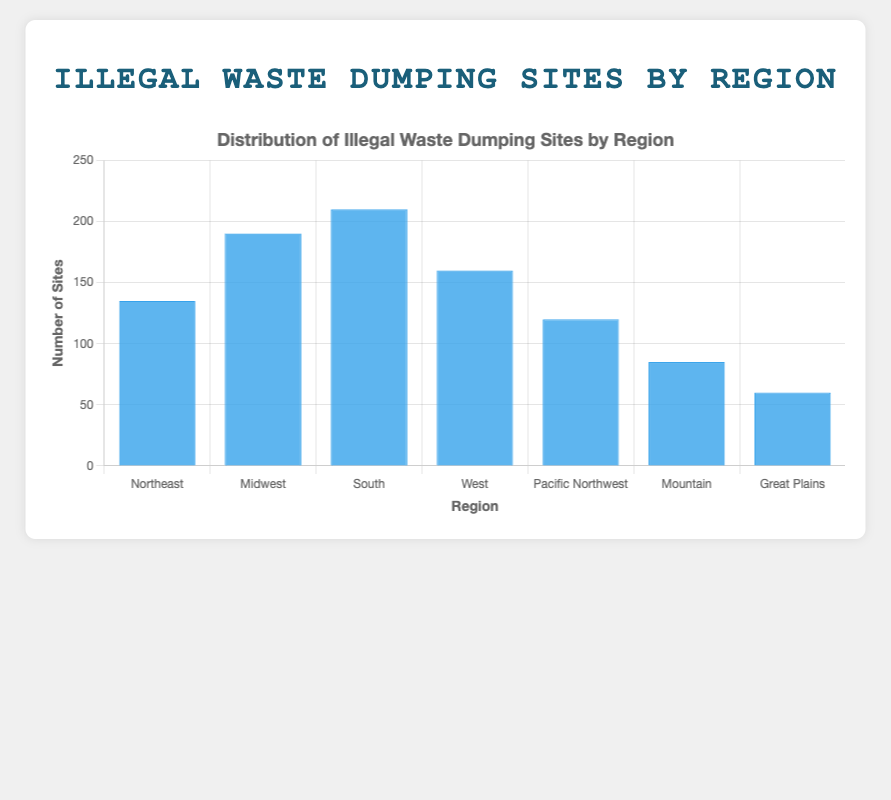Which region has the highest number of illegal waste dumping sites? Scan the bars to identify the highest one. The South has the tallest bar, indicating 210 sites.
Answer: South Which region has the fewest illegal waste dumping sites? Scan the bars to identify the shortest one. The Great Plains has the shortest bar, indicating 60 sites.
Answer: Great Plains How many more illegal waste dumping sites does the South have compared to the Midwest? Look at the respective bar heights: South = 210, Midwest = 190. Subtract Midwest from South (210 - 190).
Answer: 20 What is the difference in the number of illegal waste dumping sites between the West and the Mountain regions? Look at the respective bar heights: West = 160, Mountain = 85. Subtract Mountain from West (160 - 85).
Answer: 75 What is the total number of illegal waste dumping sites in the Northeast and Pacific Northwest regions combined? Look at the respective bar heights: Northeast = 135, Pacific Northwest = 120. Add them together (135 + 120).
Answer: 255 Is the number of illegal waste dumping sites in the Midwest greater than the number in the West? Compare the heights of the Midwest (190) and West (160) bars. The Midwest bar is taller.
Answer: Yes What is the average number of illegal waste dumping sites across all regions? Add all the site numbers (135 + 190 + 210 + 160 + 120 + 85 + 60) and divide by the number of regions (7).
Answer: 137 Which regions have more than 150 illegal waste dumping sites? Identify bars taller than the 150 mark: South (210), Midwest (190), West (160).
Answer: South, Midwest, West How many illegal waste dumping sites are there in total across all regions? Add all the site numbers (135 + 190 + 210 + 160 + 120 + 85 + 60).
Answer: 960 Arrange the regions in descending order based on the number of illegal waste dumping sites. Order the bars from tallest to shortest: South (210), Midwest (190), West (160), Northeast (135), Pacific Northwest (120), Mountain (85), Great Plains (60).
Answer: South, Midwest, West, Northeast, Pacific Northwest, Mountain, Great Plains 